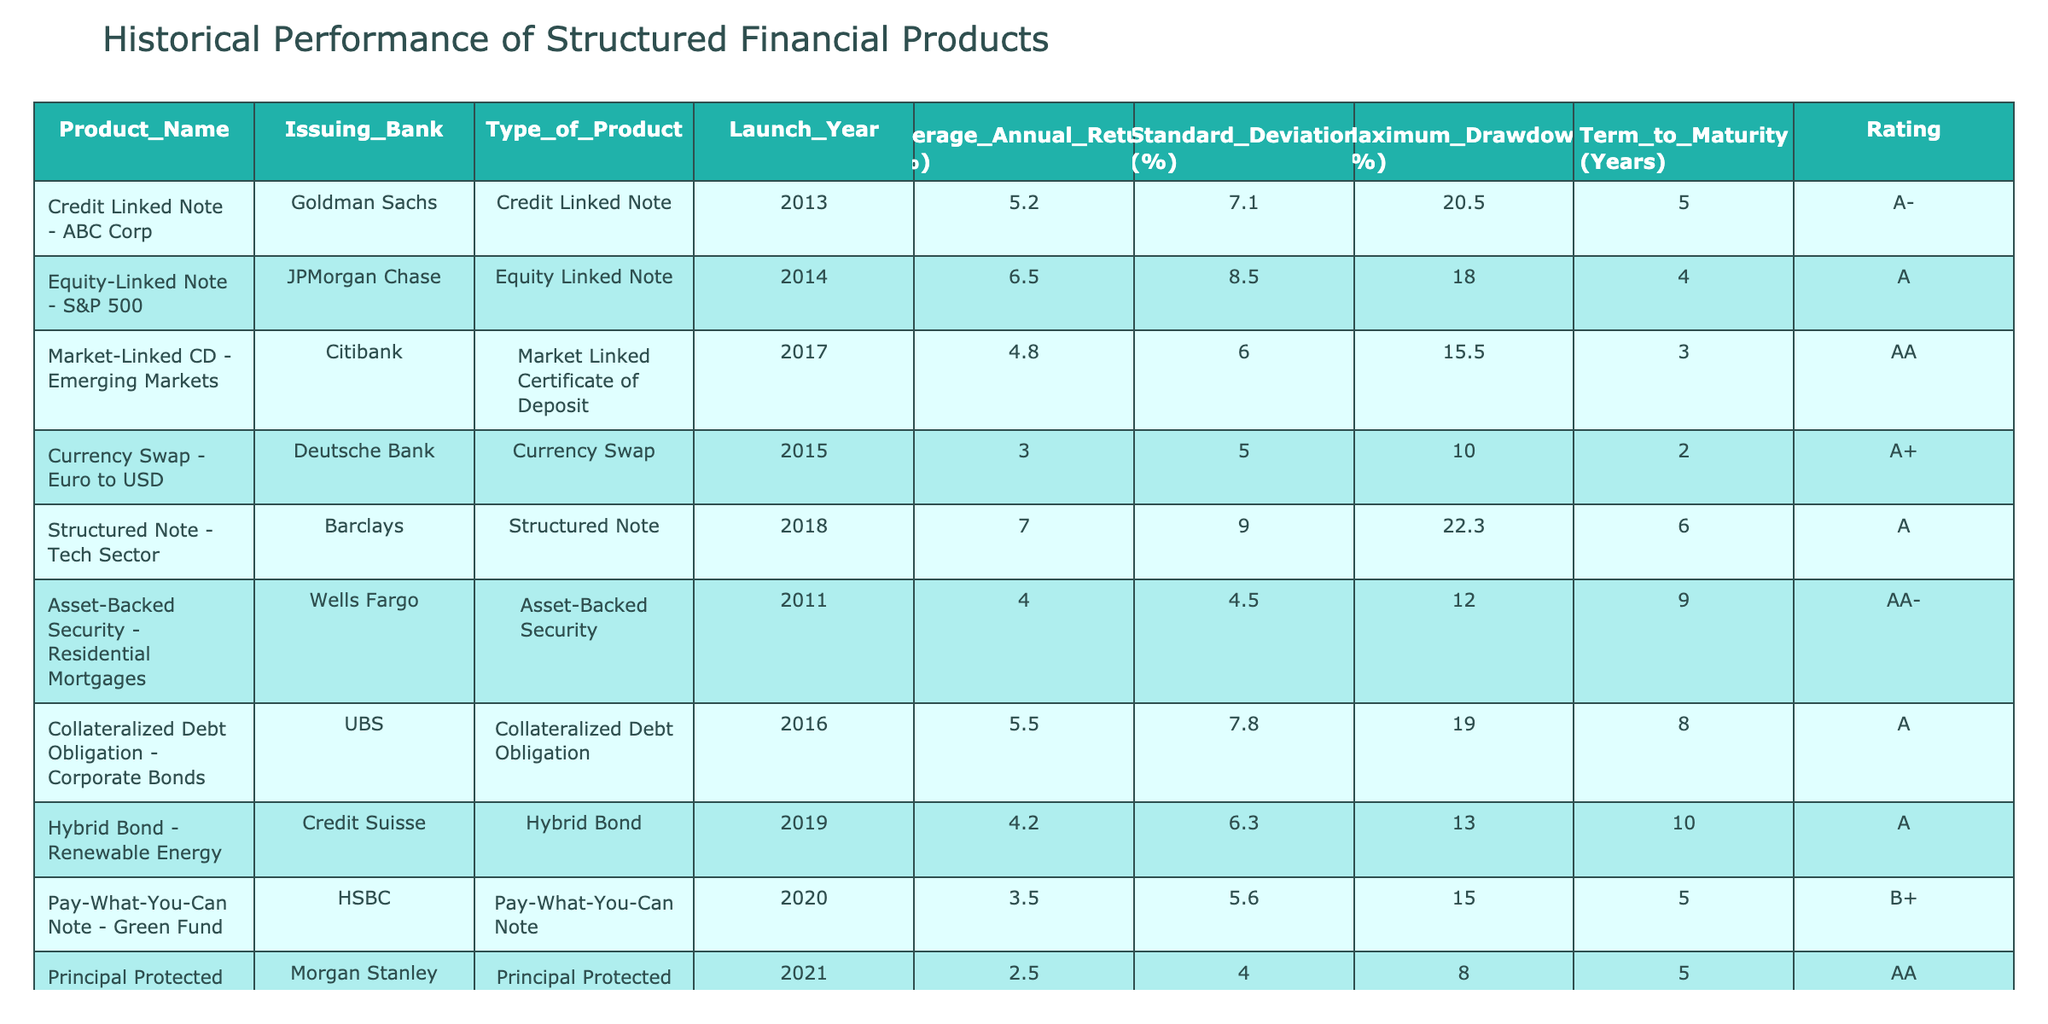What is the average annual return of the "Credit Linked Note - ABC Corp"? According to the table, the "Credit Linked Note - ABC Corp" has an average annual return of 5.2%. This value can be found directly in the corresponding row under the "Average Annual Return (%)" column.
Answer: 5.2% Which product has the highest maximum drawdown? The product with the highest maximum drawdown is the "Structured Note - Tech Sector," which has a maximum drawdown of 22.3%. This can be found by comparing the values in the "Maximum_Drawdown (%)" column for all products.
Answer: "Structured Note - Tech Sector" What is the average standard deviation of all structured financial products listed? To find the average standard deviation, we sum the standard deviation values: (7.1 + 8.5 + 6.0 + 5.0 + 9.0 + 4.5 + 7.8 + 6.3 + 5.6 + 4.0) = 64.8%. There are 10 products, so we divide by 10: 64.8% / 10 = 6.48%.
Answer: 6.48% Is the "Pay-What-You-Can Note - Green Fund" rated higher than "Principal Protected Note - Gold"? The "Pay-What-You-Can Note - Green Fund" has a rating of B+, while the "Principal Protected Note - Gold" has a rating of AA. Since AA is higher than B+, the statement is false.
Answer: No What is the total term to maturity of all products from banks rated A or higher? From the table, the rated A or higher products are: "Credit Linked Note - ABC Corp" (5 years), "Equity-Linked Note - S&P 500" (4 years), "Market-Linked CD - Emerging Markets" (3 years), "Currency Swap - Euro to USD" (2 years), "Structured Note - Tech Sector" (6 years), "Collateralized Debt Obligation - Corporate Bonds" (8 years), and "Hybrid Bond - Renewable Energy" (10 years). So, the total term to maturity is 5 + 4 + 3 + 2 + 6 + 8 + 10 = 38 years.
Answer: 38 years Which type of structured product has the lowest average annual return? By checking the values under the "Average Annual Return (%)" column, the product with the lowest average annual return is the "Principal Protected Note - Gold" at 2.5%. This makes it the lowest compared to other products in the table.
Answer: "Principal Protected Note - Gold" 